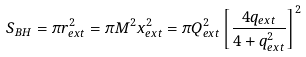Convert formula to latex. <formula><loc_0><loc_0><loc_500><loc_500>S _ { B H } = \pi r ^ { 2 } _ { e x t } = \pi M ^ { 2 } x ^ { 2 } _ { e x t } = \pi Q _ { e x t } ^ { 2 } \left [ \frac { 4 q _ { e x t } } { 4 + q ^ { 2 } _ { e x t } } \right ] ^ { 2 }</formula> 